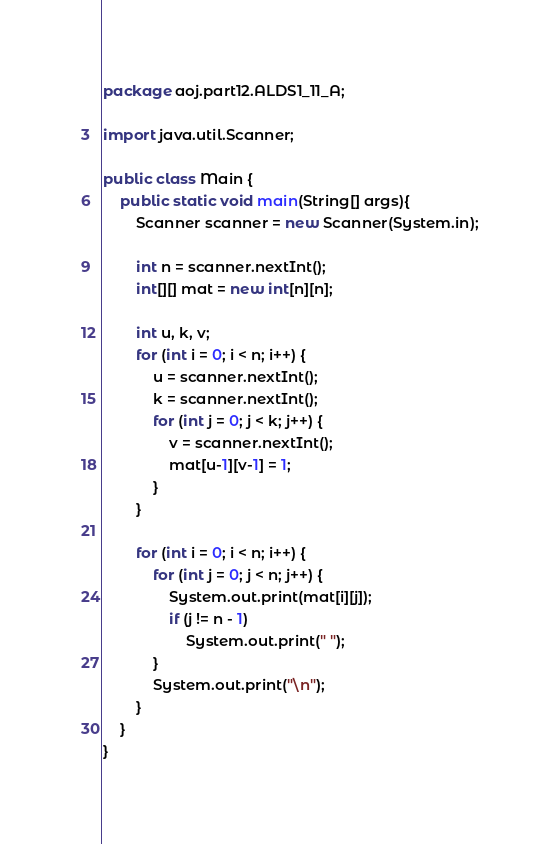<code> <loc_0><loc_0><loc_500><loc_500><_Java_>package aoj.part12.ALDS1_11_A;

import java.util.Scanner;

public class Main {
    public static void main(String[] args){
        Scanner scanner = new Scanner(System.in);

        int n = scanner.nextInt();
        int[][] mat = new int[n][n];

        int u, k, v;
        for (int i = 0; i < n; i++) {
            u = scanner.nextInt();
            k = scanner.nextInt();
            for (int j = 0; j < k; j++) {
                v = scanner.nextInt();
                mat[u-1][v-1] = 1;
            }
        }

        for (int i = 0; i < n; i++) {
            for (int j = 0; j < n; j++) {
                System.out.print(mat[i][j]);
                if (j != n - 1)
                    System.out.print(" ");
            }
            System.out.print("\n");
        }
    }
}</code> 